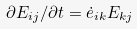<formula> <loc_0><loc_0><loc_500><loc_500>\partial E _ { i j } / \partial t = \dot { e } _ { i k } E _ { k j }</formula> 